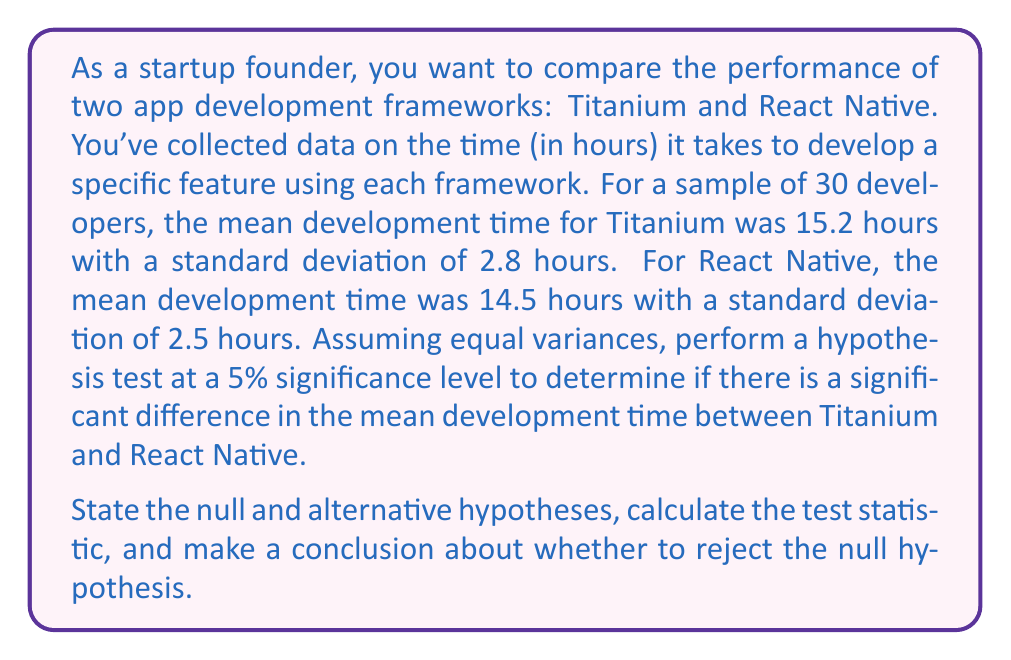Could you help me with this problem? Let's approach this step-by-step:

1) First, we need to state our hypotheses:

   $H_0: \mu_T - \mu_R = 0$ (Null hypothesis: There is no difference in mean development time)
   $H_a: \mu_T - \mu_R \neq 0$ (Alternative hypothesis: There is a difference in mean development time)

   Where $\mu_T$ is the mean for Titanium and $\mu_R$ is the mean for React Native.

2) We'll use a two-sample t-test with pooled variance, as we're assuming equal variances.

3) The formula for the t-statistic is:

   $$t = \frac{(\bar{X}_T - \bar{X}_R) - (\mu_T - \mu_R)}{S_p\sqrt{\frac{2}{n}}}$$

   Where $S_p$ is the pooled standard deviation:

   $$S_p = \sqrt{\frac{(n_1-1)S_1^2 + (n_2-1)S_2^2}{n_1+n_2-2}}$$

4) Calculate $S_p$:
   
   $$S_p = \sqrt{\frac{(30-1)(2.8)^2 + (30-1)(2.5)^2}{30+30-2}} = \sqrt{\frac{29(7.84) + 29(6.25)}{58}} = 2.657$$

5) Now calculate the t-statistic:

   $$t = \frac{(15.2 - 14.5) - 0}{2.657\sqrt{\frac{2}{30}}} = \frac{0.7}{2.657(0.258)} = 1.023$$

6) For a two-tailed test at 5% significance level, the critical values are ±1.960 (degrees of freedom = 58).

7) Since 1.023 < 1.960, we fail to reject the null hypothesis.

8) We can also calculate the p-value:
   p-value = 2 * P(T > 1.023) ≈ 0.310 (using a t-distribution calculator)

   Since 0.310 > 0.05, we again fail to reject the null hypothesis.
Answer: Fail to reject the null hypothesis. There is not enough evidence to conclude that there is a significant difference in the mean development time between Titanium and React Native at the 5% significance level (t = 1.023, p-value ≈ 0.310). 